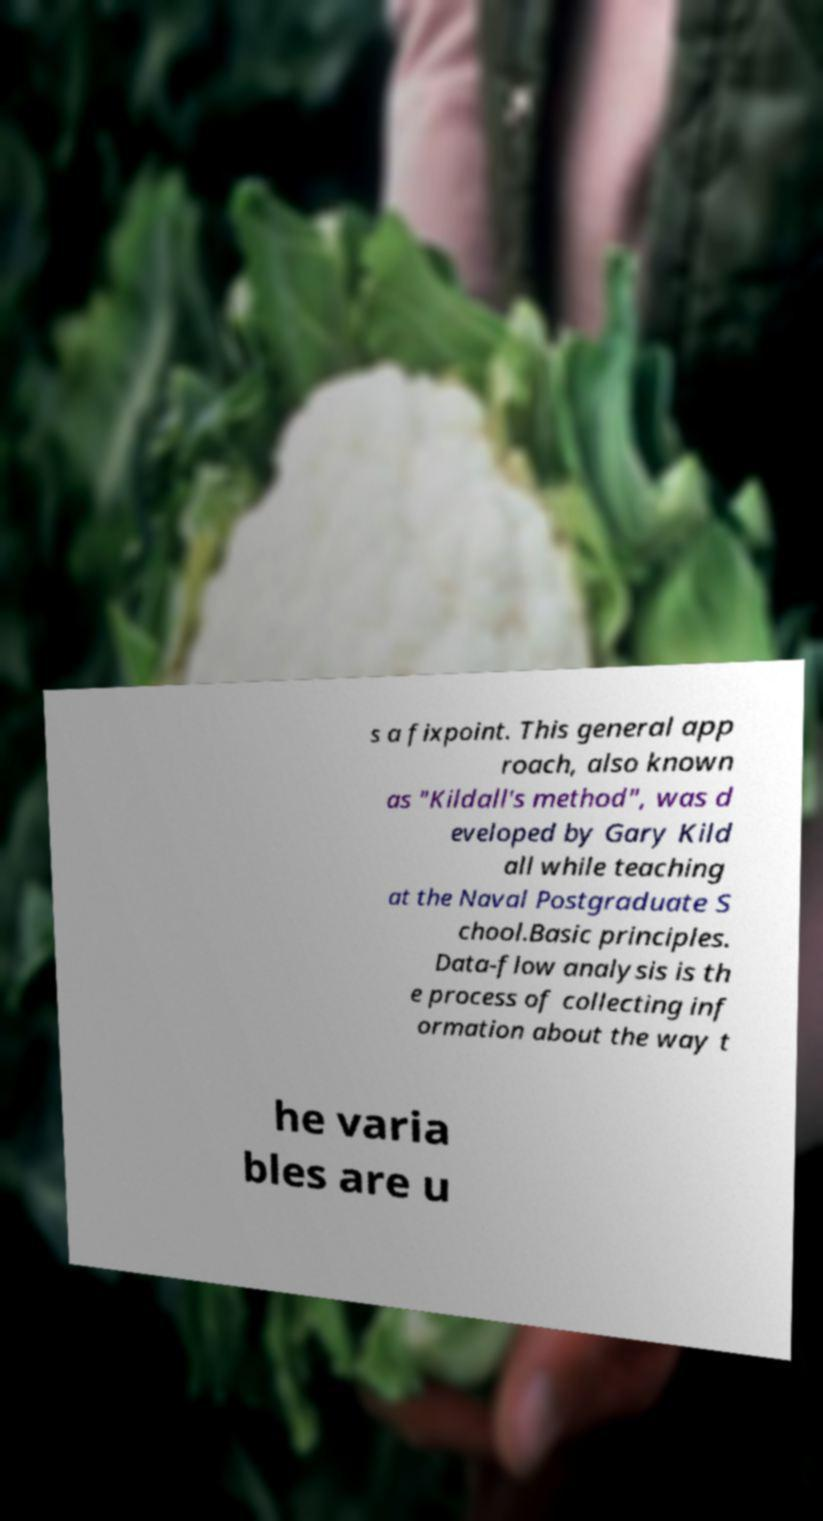There's text embedded in this image that I need extracted. Can you transcribe it verbatim? s a fixpoint. This general app roach, also known as "Kildall's method", was d eveloped by Gary Kild all while teaching at the Naval Postgraduate S chool.Basic principles. Data-flow analysis is th e process of collecting inf ormation about the way t he varia bles are u 